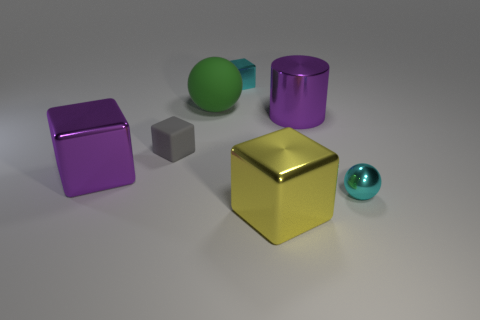There is a purple thing that is to the right of the large purple thing to the left of the rubber block; what is its shape?
Keep it short and to the point. Cylinder. Is there a small cyan thing?
Provide a succinct answer. Yes. The sphere on the right side of the cyan cube is what color?
Ensure brevity in your answer.  Cyan. There is a sphere that is the same color as the small shiny block; what material is it?
Your response must be concise. Metal. Are there any big rubber things behind the tiny cyan sphere?
Keep it short and to the point. Yes. Are there more balls than purple metal cubes?
Provide a succinct answer. Yes. There is a matte object that is to the right of the gray rubber cube that is behind the big shiny thing that is left of the big green ball; what color is it?
Ensure brevity in your answer.  Green. What is the color of the small object that is made of the same material as the large green thing?
Your answer should be very brief. Gray. What number of objects are either metallic cubes left of the large yellow metallic block or cubes to the right of the small matte cube?
Keep it short and to the point. 3. There is a cyan object that is on the left side of the cyan shiny ball; is it the same size as the cyan object that is in front of the small rubber object?
Make the answer very short. Yes. 